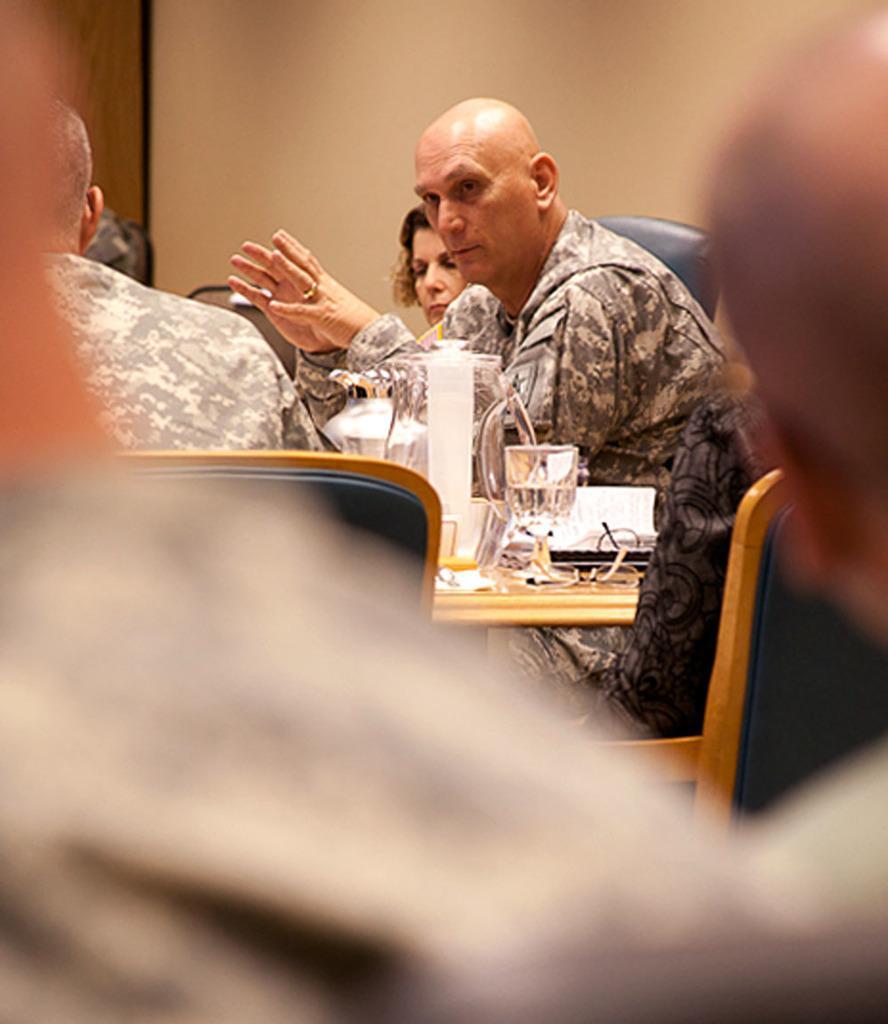Describe this image in one or two sentences. There are three people sitting on chairs and we can see glass,jar and object on the table. Background we can see wall. 